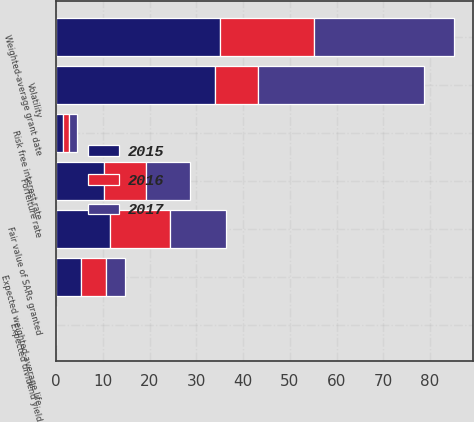Convert chart to OTSL. <chart><loc_0><loc_0><loc_500><loc_500><stacked_bar_chart><ecel><fcel>Expected dividend yield<fcel>Forfeiture rate<fcel>Volatility<fcel>Risk free interest rate<fcel>Expected weighted-average life<fcel>Fair value of SARs granted<fcel>Weighted-average grant date<nl><fcel>2017<fcel>0<fcel>9.37<fcel>35.49<fcel>1.77<fcel>4.13<fcel>12.01<fcel>29.86<nl><fcel>2016<fcel>0<fcel>9.01<fcel>9.19<fcel>1.29<fcel>5.33<fcel>12.65<fcel>20.18<nl><fcel>2015<fcel>0<fcel>10.24<fcel>33.98<fcel>1.53<fcel>5.32<fcel>11.63<fcel>35<nl></chart> 